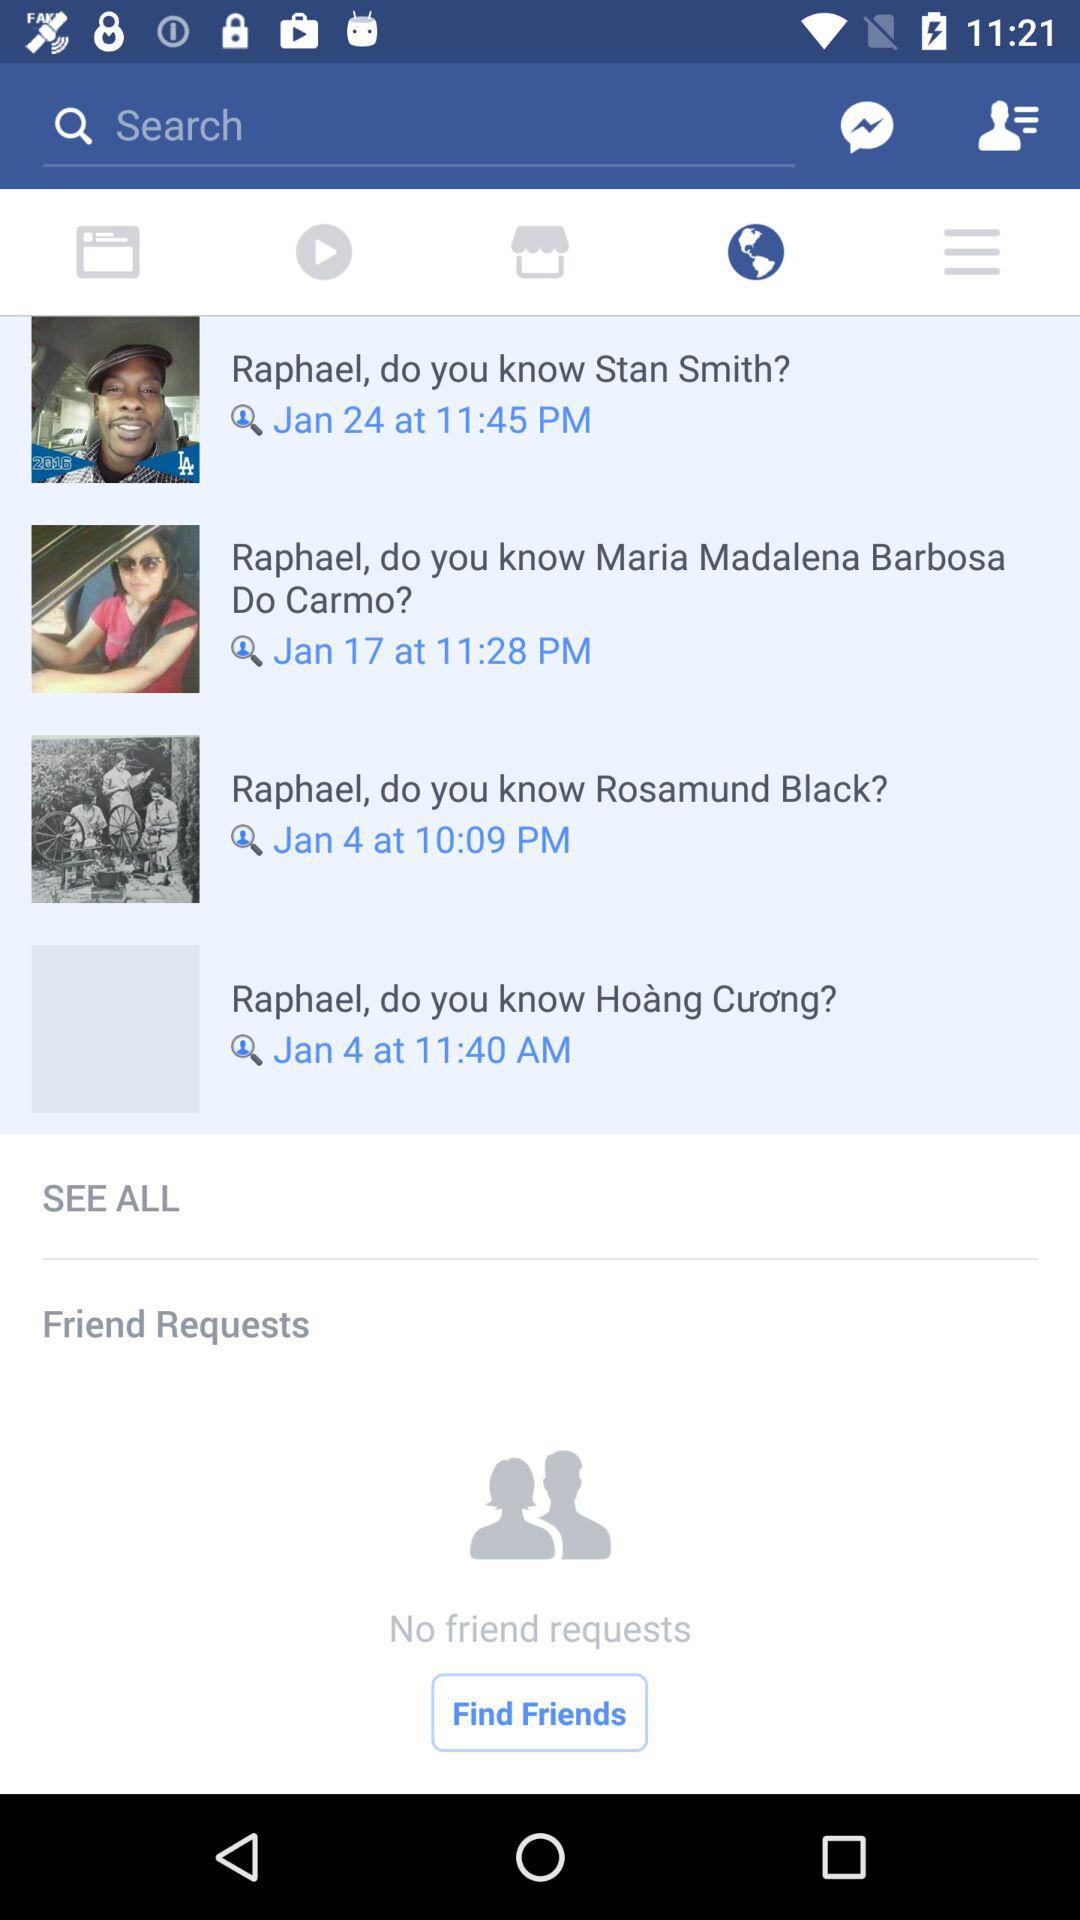How many friend requests do I have?
Answer the question using a single word or phrase. 0 